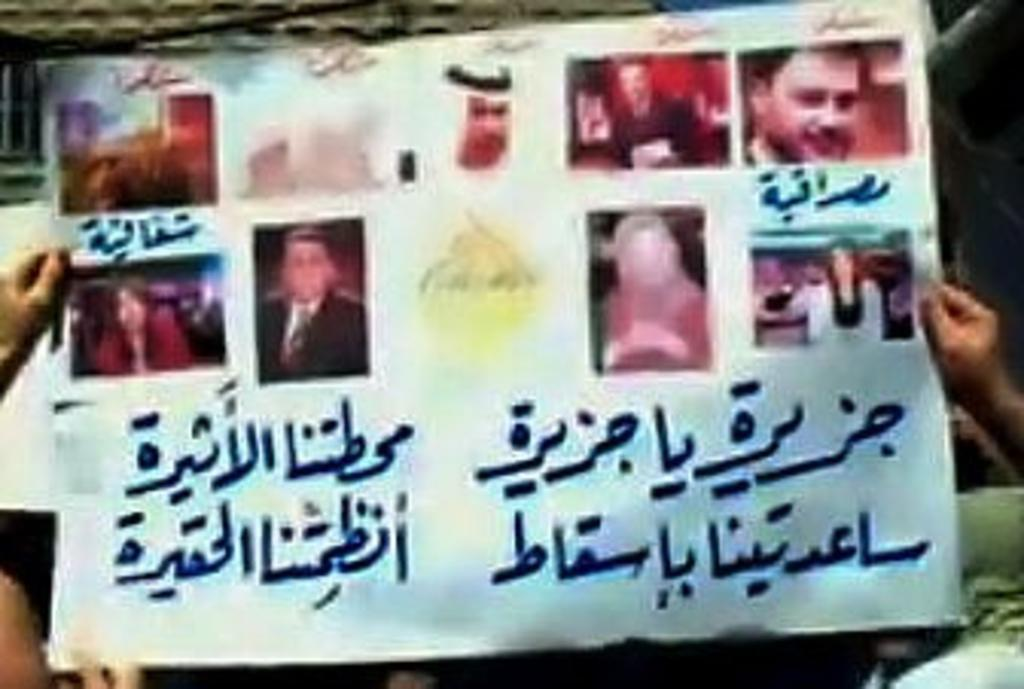What is the main subject of the image? The main subject of the image is a chart. What type of content is included in the chart? The chart contains photographs and text. Can you describe the appearance of the chart? The chart has photographs and text, and human hands are visible on either side of the image. What type of street is visible in the image? There is no street visible in the image; it features a chart with photographs and text. Where might people go to eat lunch in the image? There is no lunchroom or indication of a place to eat in the image; it only shows a chart with photographs and text. 